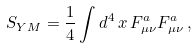<formula> <loc_0><loc_0><loc_500><loc_500>S _ { Y M } = \frac { 1 } { 4 } \int d ^ { 4 } \, x \, F _ { \mu \nu } ^ { a } F _ { \mu \nu } ^ { a } \, ,</formula> 